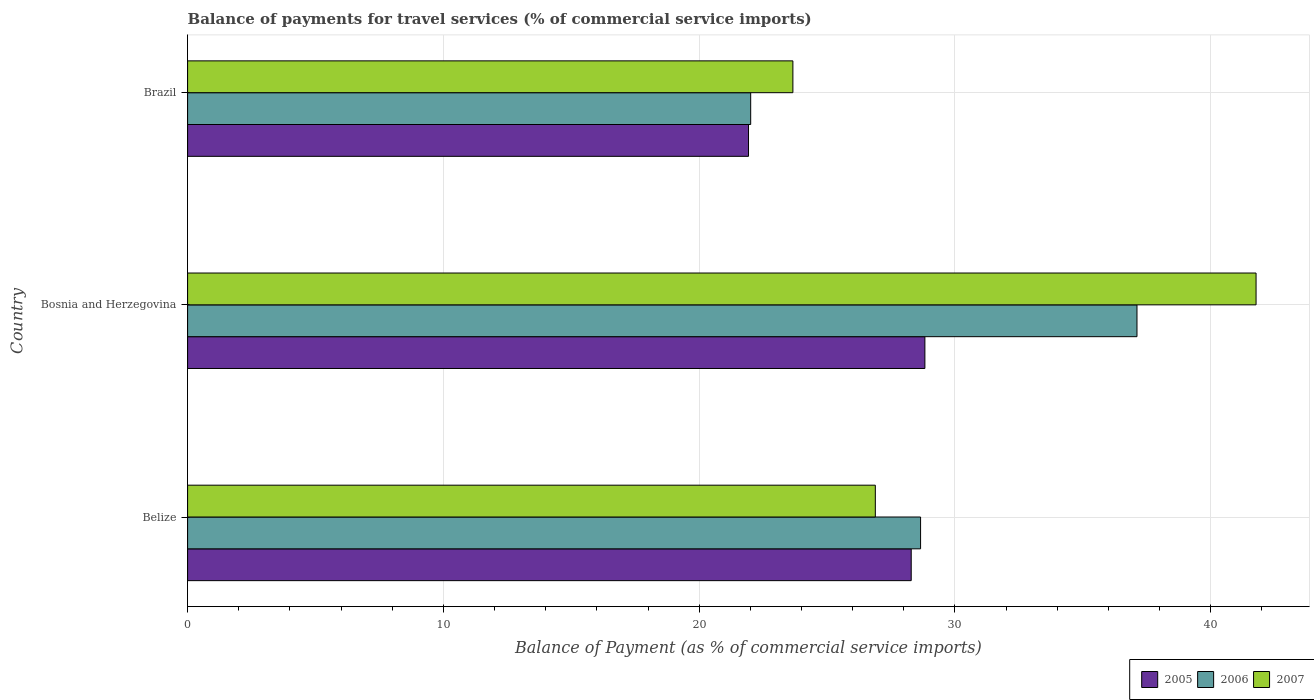Are the number of bars per tick equal to the number of legend labels?
Ensure brevity in your answer.  Yes. How many bars are there on the 3rd tick from the top?
Provide a short and direct response. 3. What is the label of the 3rd group of bars from the top?
Your answer should be very brief. Belize. What is the balance of payments for travel services in 2005 in Belize?
Ensure brevity in your answer.  28.29. Across all countries, what is the maximum balance of payments for travel services in 2007?
Give a very brief answer. 41.77. Across all countries, what is the minimum balance of payments for travel services in 2005?
Your response must be concise. 21.93. In which country was the balance of payments for travel services in 2007 maximum?
Offer a very short reply. Bosnia and Herzegovina. What is the total balance of payments for travel services in 2006 in the graph?
Keep it short and to the point. 87.78. What is the difference between the balance of payments for travel services in 2005 in Bosnia and Herzegovina and that in Brazil?
Make the answer very short. 6.9. What is the difference between the balance of payments for travel services in 2007 in Bosnia and Herzegovina and the balance of payments for travel services in 2005 in Brazil?
Make the answer very short. 19.84. What is the average balance of payments for travel services in 2005 per country?
Offer a terse response. 26.35. What is the difference between the balance of payments for travel services in 2005 and balance of payments for travel services in 2007 in Bosnia and Herzegovina?
Ensure brevity in your answer.  -12.95. In how many countries, is the balance of payments for travel services in 2007 greater than 18 %?
Ensure brevity in your answer.  3. What is the ratio of the balance of payments for travel services in 2006 in Bosnia and Herzegovina to that in Brazil?
Make the answer very short. 1.69. Is the difference between the balance of payments for travel services in 2005 in Belize and Bosnia and Herzegovina greater than the difference between the balance of payments for travel services in 2007 in Belize and Bosnia and Herzegovina?
Give a very brief answer. Yes. What is the difference between the highest and the second highest balance of payments for travel services in 2006?
Your response must be concise. 8.46. What is the difference between the highest and the lowest balance of payments for travel services in 2007?
Keep it short and to the point. 18.11. What does the 2nd bar from the bottom in Bosnia and Herzegovina represents?
Keep it short and to the point. 2006. How many bars are there?
Ensure brevity in your answer.  9. Are all the bars in the graph horizontal?
Provide a short and direct response. Yes. How many countries are there in the graph?
Provide a short and direct response. 3. What is the difference between two consecutive major ticks on the X-axis?
Offer a terse response. 10. Are the values on the major ticks of X-axis written in scientific E-notation?
Ensure brevity in your answer.  No. Does the graph contain any zero values?
Offer a very short reply. No. Does the graph contain grids?
Make the answer very short. Yes. How many legend labels are there?
Provide a short and direct response. 3. What is the title of the graph?
Offer a very short reply. Balance of payments for travel services (% of commercial service imports). Does "1987" appear as one of the legend labels in the graph?
Ensure brevity in your answer.  No. What is the label or title of the X-axis?
Provide a succinct answer. Balance of Payment (as % of commercial service imports). What is the label or title of the Y-axis?
Offer a terse response. Country. What is the Balance of Payment (as % of commercial service imports) of 2005 in Belize?
Offer a very short reply. 28.29. What is the Balance of Payment (as % of commercial service imports) in 2006 in Belize?
Offer a terse response. 28.66. What is the Balance of Payment (as % of commercial service imports) of 2007 in Belize?
Offer a very short reply. 26.89. What is the Balance of Payment (as % of commercial service imports) in 2005 in Bosnia and Herzegovina?
Keep it short and to the point. 28.82. What is the Balance of Payment (as % of commercial service imports) of 2006 in Bosnia and Herzegovina?
Your response must be concise. 37.12. What is the Balance of Payment (as % of commercial service imports) in 2007 in Bosnia and Herzegovina?
Provide a short and direct response. 41.77. What is the Balance of Payment (as % of commercial service imports) in 2005 in Brazil?
Provide a succinct answer. 21.93. What is the Balance of Payment (as % of commercial service imports) of 2006 in Brazil?
Make the answer very short. 22.01. What is the Balance of Payment (as % of commercial service imports) of 2007 in Brazil?
Provide a short and direct response. 23.66. Across all countries, what is the maximum Balance of Payment (as % of commercial service imports) of 2005?
Keep it short and to the point. 28.82. Across all countries, what is the maximum Balance of Payment (as % of commercial service imports) in 2006?
Provide a succinct answer. 37.12. Across all countries, what is the maximum Balance of Payment (as % of commercial service imports) in 2007?
Provide a succinct answer. 41.77. Across all countries, what is the minimum Balance of Payment (as % of commercial service imports) of 2005?
Offer a terse response. 21.93. Across all countries, what is the minimum Balance of Payment (as % of commercial service imports) in 2006?
Offer a very short reply. 22.01. Across all countries, what is the minimum Balance of Payment (as % of commercial service imports) of 2007?
Make the answer very short. 23.66. What is the total Balance of Payment (as % of commercial service imports) of 2005 in the graph?
Provide a short and direct response. 79.04. What is the total Balance of Payment (as % of commercial service imports) of 2006 in the graph?
Offer a very short reply. 87.78. What is the total Balance of Payment (as % of commercial service imports) of 2007 in the graph?
Ensure brevity in your answer.  92.32. What is the difference between the Balance of Payment (as % of commercial service imports) of 2005 in Belize and that in Bosnia and Herzegovina?
Offer a terse response. -0.53. What is the difference between the Balance of Payment (as % of commercial service imports) in 2006 in Belize and that in Bosnia and Herzegovina?
Provide a short and direct response. -8.46. What is the difference between the Balance of Payment (as % of commercial service imports) of 2007 in Belize and that in Bosnia and Herzegovina?
Your answer should be compact. -14.88. What is the difference between the Balance of Payment (as % of commercial service imports) of 2005 in Belize and that in Brazil?
Provide a short and direct response. 6.36. What is the difference between the Balance of Payment (as % of commercial service imports) of 2006 in Belize and that in Brazil?
Give a very brief answer. 6.64. What is the difference between the Balance of Payment (as % of commercial service imports) of 2007 in Belize and that in Brazil?
Give a very brief answer. 3.22. What is the difference between the Balance of Payment (as % of commercial service imports) of 2005 in Bosnia and Herzegovina and that in Brazil?
Your answer should be compact. 6.9. What is the difference between the Balance of Payment (as % of commercial service imports) in 2006 in Bosnia and Herzegovina and that in Brazil?
Your response must be concise. 15.1. What is the difference between the Balance of Payment (as % of commercial service imports) in 2007 in Bosnia and Herzegovina and that in Brazil?
Give a very brief answer. 18.11. What is the difference between the Balance of Payment (as % of commercial service imports) in 2005 in Belize and the Balance of Payment (as % of commercial service imports) in 2006 in Bosnia and Herzegovina?
Your response must be concise. -8.83. What is the difference between the Balance of Payment (as % of commercial service imports) in 2005 in Belize and the Balance of Payment (as % of commercial service imports) in 2007 in Bosnia and Herzegovina?
Offer a terse response. -13.48. What is the difference between the Balance of Payment (as % of commercial service imports) of 2006 in Belize and the Balance of Payment (as % of commercial service imports) of 2007 in Bosnia and Herzegovina?
Provide a short and direct response. -13.12. What is the difference between the Balance of Payment (as % of commercial service imports) of 2005 in Belize and the Balance of Payment (as % of commercial service imports) of 2006 in Brazil?
Your answer should be compact. 6.28. What is the difference between the Balance of Payment (as % of commercial service imports) of 2005 in Belize and the Balance of Payment (as % of commercial service imports) of 2007 in Brazil?
Offer a terse response. 4.63. What is the difference between the Balance of Payment (as % of commercial service imports) in 2006 in Belize and the Balance of Payment (as % of commercial service imports) in 2007 in Brazil?
Your answer should be very brief. 4.99. What is the difference between the Balance of Payment (as % of commercial service imports) of 2005 in Bosnia and Herzegovina and the Balance of Payment (as % of commercial service imports) of 2006 in Brazil?
Give a very brief answer. 6.81. What is the difference between the Balance of Payment (as % of commercial service imports) of 2005 in Bosnia and Herzegovina and the Balance of Payment (as % of commercial service imports) of 2007 in Brazil?
Your answer should be very brief. 5.16. What is the difference between the Balance of Payment (as % of commercial service imports) of 2006 in Bosnia and Herzegovina and the Balance of Payment (as % of commercial service imports) of 2007 in Brazil?
Ensure brevity in your answer.  13.45. What is the average Balance of Payment (as % of commercial service imports) in 2005 per country?
Give a very brief answer. 26.35. What is the average Balance of Payment (as % of commercial service imports) of 2006 per country?
Provide a short and direct response. 29.26. What is the average Balance of Payment (as % of commercial service imports) of 2007 per country?
Make the answer very short. 30.77. What is the difference between the Balance of Payment (as % of commercial service imports) of 2005 and Balance of Payment (as % of commercial service imports) of 2006 in Belize?
Provide a short and direct response. -0.37. What is the difference between the Balance of Payment (as % of commercial service imports) in 2005 and Balance of Payment (as % of commercial service imports) in 2007 in Belize?
Provide a short and direct response. 1.4. What is the difference between the Balance of Payment (as % of commercial service imports) in 2006 and Balance of Payment (as % of commercial service imports) in 2007 in Belize?
Ensure brevity in your answer.  1.77. What is the difference between the Balance of Payment (as % of commercial service imports) of 2005 and Balance of Payment (as % of commercial service imports) of 2006 in Bosnia and Herzegovina?
Your answer should be very brief. -8.29. What is the difference between the Balance of Payment (as % of commercial service imports) of 2005 and Balance of Payment (as % of commercial service imports) of 2007 in Bosnia and Herzegovina?
Your answer should be very brief. -12.95. What is the difference between the Balance of Payment (as % of commercial service imports) of 2006 and Balance of Payment (as % of commercial service imports) of 2007 in Bosnia and Herzegovina?
Keep it short and to the point. -4.66. What is the difference between the Balance of Payment (as % of commercial service imports) in 2005 and Balance of Payment (as % of commercial service imports) in 2006 in Brazil?
Ensure brevity in your answer.  -0.09. What is the difference between the Balance of Payment (as % of commercial service imports) of 2005 and Balance of Payment (as % of commercial service imports) of 2007 in Brazil?
Your answer should be very brief. -1.74. What is the difference between the Balance of Payment (as % of commercial service imports) of 2006 and Balance of Payment (as % of commercial service imports) of 2007 in Brazil?
Offer a very short reply. -1.65. What is the ratio of the Balance of Payment (as % of commercial service imports) of 2005 in Belize to that in Bosnia and Herzegovina?
Your answer should be very brief. 0.98. What is the ratio of the Balance of Payment (as % of commercial service imports) in 2006 in Belize to that in Bosnia and Herzegovina?
Offer a terse response. 0.77. What is the ratio of the Balance of Payment (as % of commercial service imports) in 2007 in Belize to that in Bosnia and Herzegovina?
Your answer should be compact. 0.64. What is the ratio of the Balance of Payment (as % of commercial service imports) in 2005 in Belize to that in Brazil?
Your answer should be compact. 1.29. What is the ratio of the Balance of Payment (as % of commercial service imports) in 2006 in Belize to that in Brazil?
Offer a terse response. 1.3. What is the ratio of the Balance of Payment (as % of commercial service imports) in 2007 in Belize to that in Brazil?
Make the answer very short. 1.14. What is the ratio of the Balance of Payment (as % of commercial service imports) of 2005 in Bosnia and Herzegovina to that in Brazil?
Provide a short and direct response. 1.31. What is the ratio of the Balance of Payment (as % of commercial service imports) of 2006 in Bosnia and Herzegovina to that in Brazil?
Your response must be concise. 1.69. What is the ratio of the Balance of Payment (as % of commercial service imports) in 2007 in Bosnia and Herzegovina to that in Brazil?
Offer a terse response. 1.77. What is the difference between the highest and the second highest Balance of Payment (as % of commercial service imports) in 2005?
Your answer should be very brief. 0.53. What is the difference between the highest and the second highest Balance of Payment (as % of commercial service imports) in 2006?
Offer a very short reply. 8.46. What is the difference between the highest and the second highest Balance of Payment (as % of commercial service imports) in 2007?
Make the answer very short. 14.88. What is the difference between the highest and the lowest Balance of Payment (as % of commercial service imports) of 2005?
Provide a succinct answer. 6.9. What is the difference between the highest and the lowest Balance of Payment (as % of commercial service imports) of 2006?
Ensure brevity in your answer.  15.1. What is the difference between the highest and the lowest Balance of Payment (as % of commercial service imports) of 2007?
Keep it short and to the point. 18.11. 